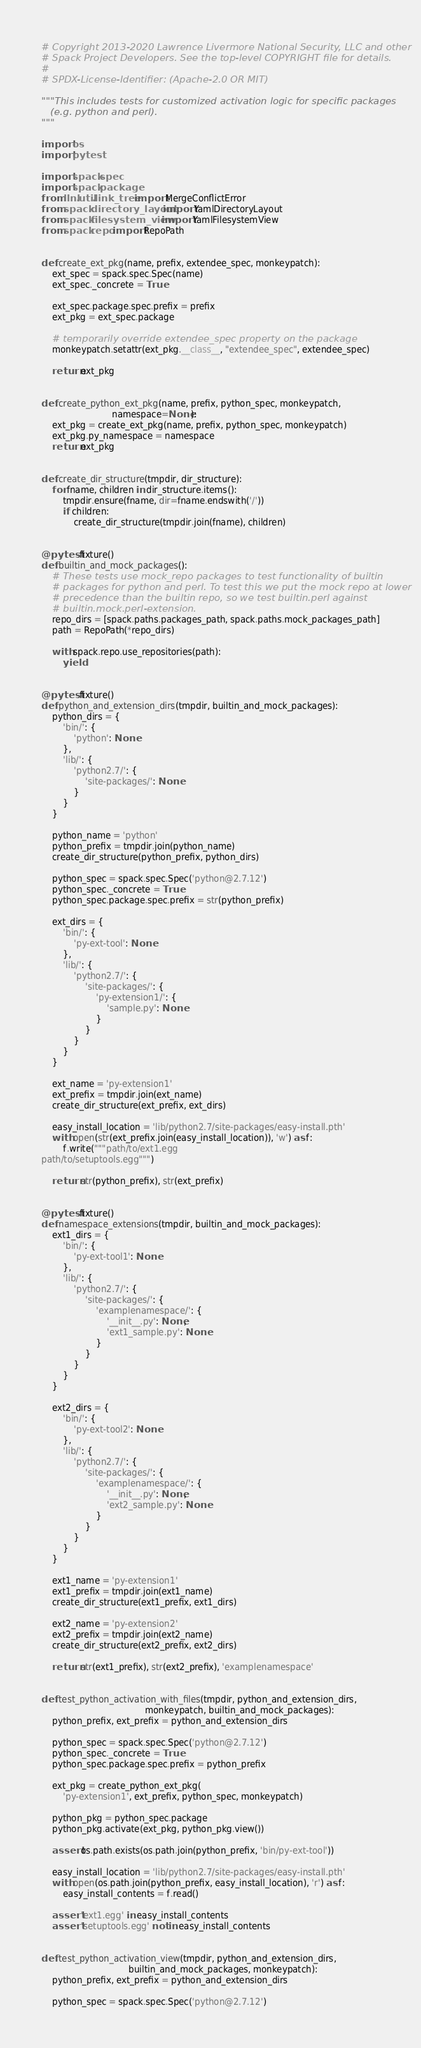Convert code to text. <code><loc_0><loc_0><loc_500><loc_500><_Python_># Copyright 2013-2020 Lawrence Livermore National Security, LLC and other
# Spack Project Developers. See the top-level COPYRIGHT file for details.
#
# SPDX-License-Identifier: (Apache-2.0 OR MIT)

"""This includes tests for customized activation logic for specific packages
   (e.g. python and perl).
"""

import os
import pytest

import spack.spec
import spack.package
from llnl.util.link_tree import MergeConflictError
from spack.directory_layout import YamlDirectoryLayout
from spack.filesystem_view import YamlFilesystemView
from spack.repo import RepoPath


def create_ext_pkg(name, prefix, extendee_spec, monkeypatch):
    ext_spec = spack.spec.Spec(name)
    ext_spec._concrete = True

    ext_spec.package.spec.prefix = prefix
    ext_pkg = ext_spec.package

    # temporarily override extendee_spec property on the package
    monkeypatch.setattr(ext_pkg.__class__, "extendee_spec", extendee_spec)

    return ext_pkg


def create_python_ext_pkg(name, prefix, python_spec, monkeypatch,
                          namespace=None):
    ext_pkg = create_ext_pkg(name, prefix, python_spec, monkeypatch)
    ext_pkg.py_namespace = namespace
    return ext_pkg


def create_dir_structure(tmpdir, dir_structure):
    for fname, children in dir_structure.items():
        tmpdir.ensure(fname, dir=fname.endswith('/'))
        if children:
            create_dir_structure(tmpdir.join(fname), children)


@pytest.fixture()
def builtin_and_mock_packages():
    # These tests use mock_repo packages to test functionality of builtin
    # packages for python and perl. To test this we put the mock repo at lower
    # precedence than the builtin repo, so we test builtin.perl against
    # builtin.mock.perl-extension.
    repo_dirs = [spack.paths.packages_path, spack.paths.mock_packages_path]
    path = RepoPath(*repo_dirs)

    with spack.repo.use_repositories(path):
        yield


@pytest.fixture()
def python_and_extension_dirs(tmpdir, builtin_and_mock_packages):
    python_dirs = {
        'bin/': {
            'python': None
        },
        'lib/': {
            'python2.7/': {
                'site-packages/': None
            }
        }
    }

    python_name = 'python'
    python_prefix = tmpdir.join(python_name)
    create_dir_structure(python_prefix, python_dirs)

    python_spec = spack.spec.Spec('python@2.7.12')
    python_spec._concrete = True
    python_spec.package.spec.prefix = str(python_prefix)

    ext_dirs = {
        'bin/': {
            'py-ext-tool': None
        },
        'lib/': {
            'python2.7/': {
                'site-packages/': {
                    'py-extension1/': {
                        'sample.py': None
                    }
                }
            }
        }
    }

    ext_name = 'py-extension1'
    ext_prefix = tmpdir.join(ext_name)
    create_dir_structure(ext_prefix, ext_dirs)

    easy_install_location = 'lib/python2.7/site-packages/easy-install.pth'
    with open(str(ext_prefix.join(easy_install_location)), 'w') as f:
        f.write("""path/to/ext1.egg
path/to/setuptools.egg""")

    return str(python_prefix), str(ext_prefix)


@pytest.fixture()
def namespace_extensions(tmpdir, builtin_and_mock_packages):
    ext1_dirs = {
        'bin/': {
            'py-ext-tool1': None
        },
        'lib/': {
            'python2.7/': {
                'site-packages/': {
                    'examplenamespace/': {
                        '__init__.py': None,
                        'ext1_sample.py': None
                    }
                }
            }
        }
    }

    ext2_dirs = {
        'bin/': {
            'py-ext-tool2': None
        },
        'lib/': {
            'python2.7/': {
                'site-packages/': {
                    'examplenamespace/': {
                        '__init__.py': None,
                        'ext2_sample.py': None
                    }
                }
            }
        }
    }

    ext1_name = 'py-extension1'
    ext1_prefix = tmpdir.join(ext1_name)
    create_dir_structure(ext1_prefix, ext1_dirs)

    ext2_name = 'py-extension2'
    ext2_prefix = tmpdir.join(ext2_name)
    create_dir_structure(ext2_prefix, ext2_dirs)

    return str(ext1_prefix), str(ext2_prefix), 'examplenamespace'


def test_python_activation_with_files(tmpdir, python_and_extension_dirs,
                                      monkeypatch, builtin_and_mock_packages):
    python_prefix, ext_prefix = python_and_extension_dirs

    python_spec = spack.spec.Spec('python@2.7.12')
    python_spec._concrete = True
    python_spec.package.spec.prefix = python_prefix

    ext_pkg = create_python_ext_pkg(
        'py-extension1', ext_prefix, python_spec, monkeypatch)

    python_pkg = python_spec.package
    python_pkg.activate(ext_pkg, python_pkg.view())

    assert os.path.exists(os.path.join(python_prefix, 'bin/py-ext-tool'))

    easy_install_location = 'lib/python2.7/site-packages/easy-install.pth'
    with open(os.path.join(python_prefix, easy_install_location), 'r') as f:
        easy_install_contents = f.read()

    assert 'ext1.egg' in easy_install_contents
    assert 'setuptools.egg' not in easy_install_contents


def test_python_activation_view(tmpdir, python_and_extension_dirs,
                                builtin_and_mock_packages, monkeypatch):
    python_prefix, ext_prefix = python_and_extension_dirs

    python_spec = spack.spec.Spec('python@2.7.12')</code> 